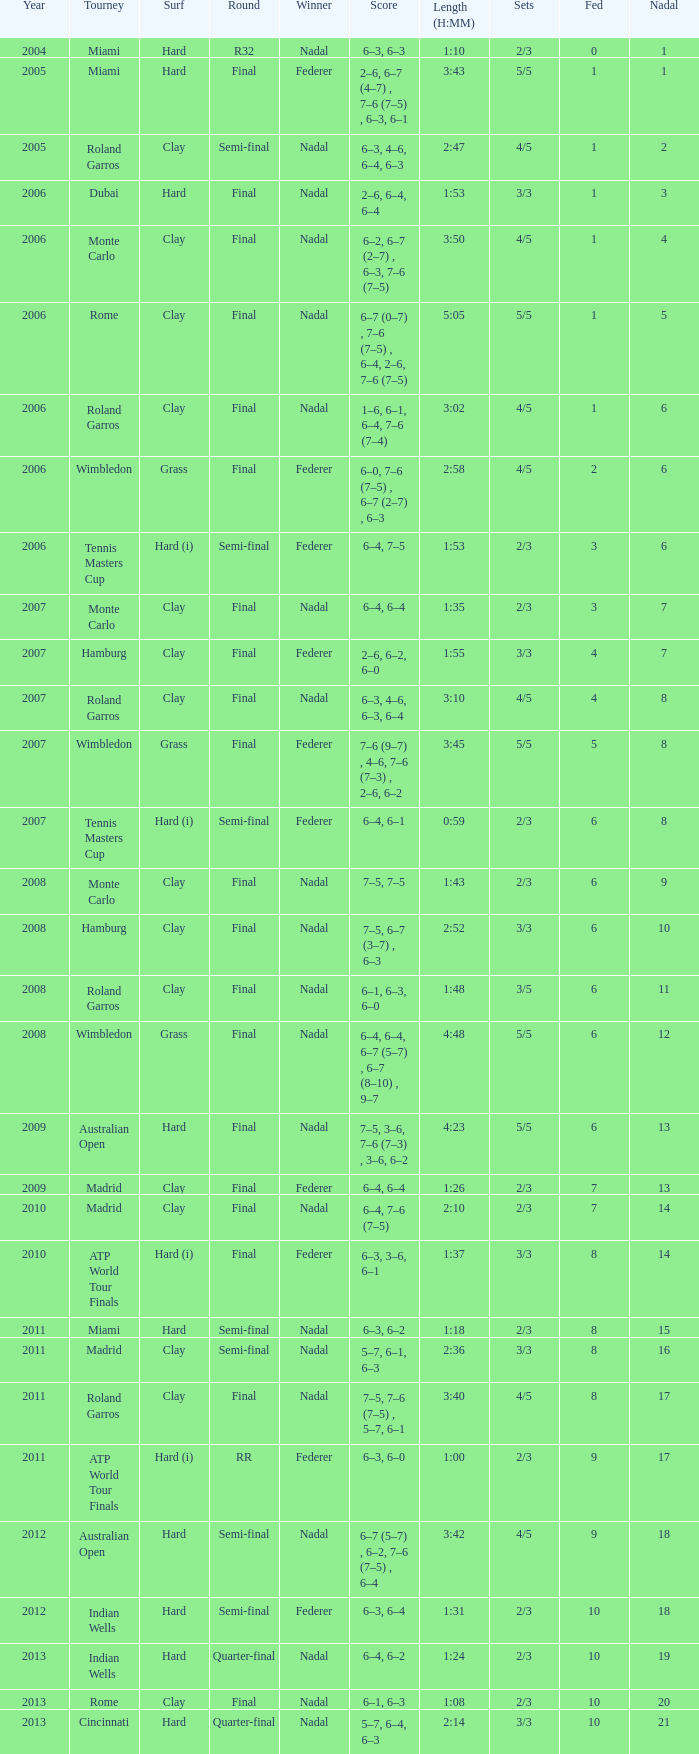What tournament did Nadal win and had a nadal of 16? Madrid. 